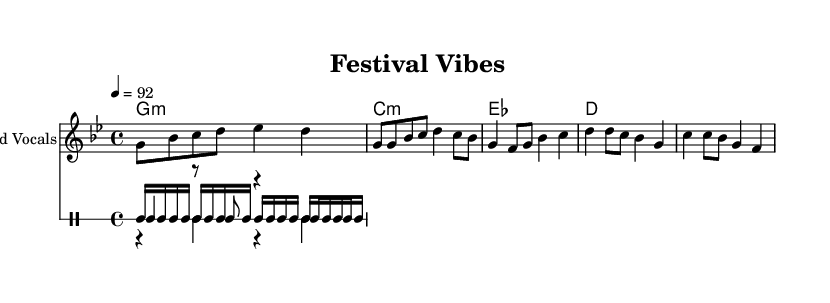What is the key signature of this music? The key signature is G minor, which has two flats (B flat and E flat). You can determine the key signature by looking at the beginning of the staff where the key signatures are indicated.
Answer: G minor What is the time signature of this music? The time signature is 4/4, which indicates there are four beats in each measure and the quarter note gets one beat. This can be found at the beginning of the score written as "4/4."
Answer: 4/4 What is the tempo marking of this music? The tempo marking indicates a speed of 92 beats per minute. This is explicitly noted in the score after the time signature, represented as "4 = 92."
Answer: 92 What are the main instruments featured in this score? The main instruments featured are Lead Vocals and Drums. This can be understood by looking at the part names given for each staff in the score.
Answer: Lead Vocals and Drums How many vocals lines are there in the melody? There is one vocal line in the melody. The score specifies only one "Lead Vocals" staff, indicating a singular vocal track.
Answer: One What is the title of this piece? The title of the piece is "Festival Vibes." The title is located at the top of the score under the header section.
Answer: Festival Vibes What phrase is repeated in the chorus? The repeated phrase in the chorus is "Festival vibes, we're all alive." This phrase can be identified in the lyrics section under the "Chorus" part.
Answer: Festival vibes, we're all alive 